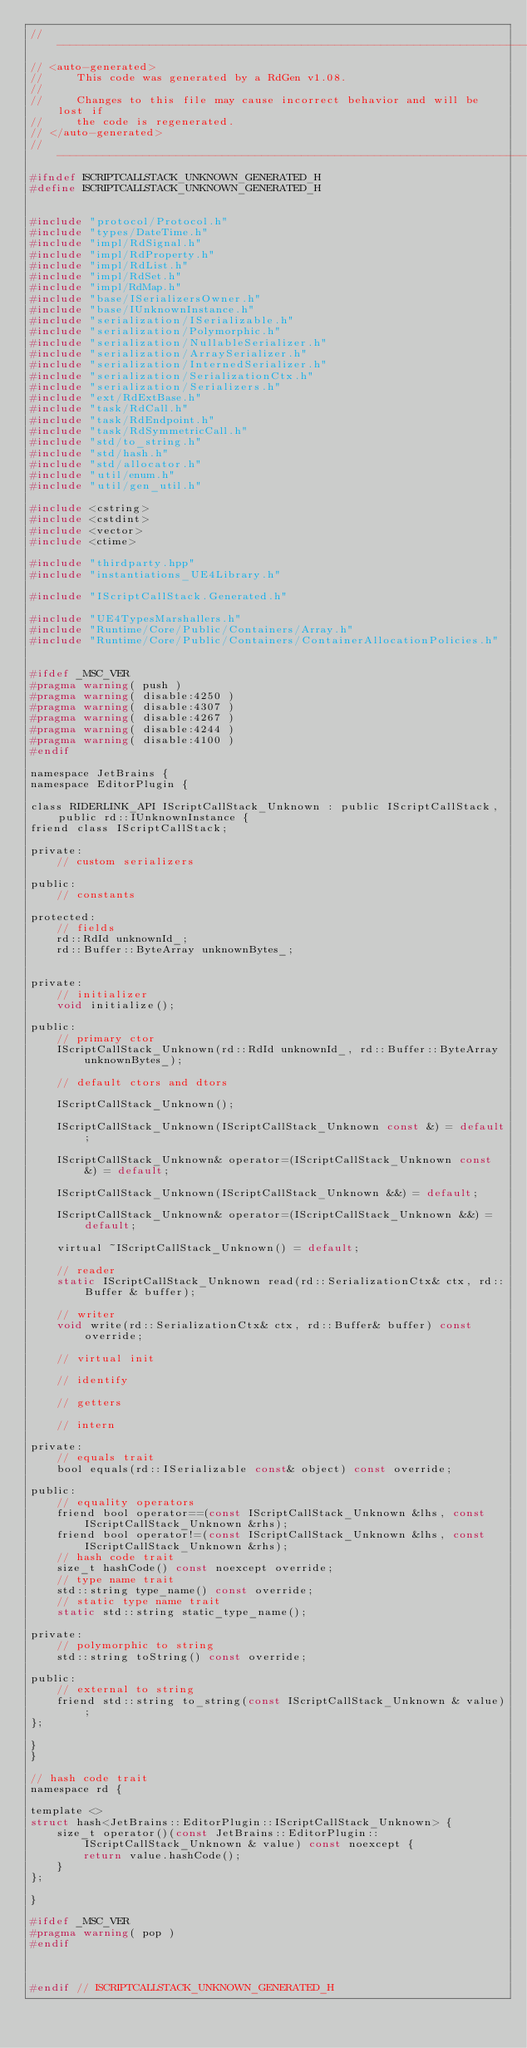<code> <loc_0><loc_0><loc_500><loc_500><_C_>//------------------------------------------------------------------------------
// <auto-generated>
//     This code was generated by a RdGen v1.08.
//
//     Changes to this file may cause incorrect behavior and will be lost if
//     the code is regenerated.
// </auto-generated>
//------------------------------------------------------------------------------
#ifndef ISCRIPTCALLSTACK_UNKNOWN_GENERATED_H
#define ISCRIPTCALLSTACK_UNKNOWN_GENERATED_H


#include "protocol/Protocol.h"
#include "types/DateTime.h"
#include "impl/RdSignal.h"
#include "impl/RdProperty.h"
#include "impl/RdList.h"
#include "impl/RdSet.h"
#include "impl/RdMap.h"
#include "base/ISerializersOwner.h"
#include "base/IUnknownInstance.h"
#include "serialization/ISerializable.h"
#include "serialization/Polymorphic.h"
#include "serialization/NullableSerializer.h"
#include "serialization/ArraySerializer.h"
#include "serialization/InternedSerializer.h"
#include "serialization/SerializationCtx.h"
#include "serialization/Serializers.h"
#include "ext/RdExtBase.h"
#include "task/RdCall.h"
#include "task/RdEndpoint.h"
#include "task/RdSymmetricCall.h"
#include "std/to_string.h"
#include "std/hash.h"
#include "std/allocator.h"
#include "util/enum.h"
#include "util/gen_util.h"

#include <cstring>
#include <cstdint>
#include <vector>
#include <ctime>

#include "thirdparty.hpp"
#include "instantiations_UE4Library.h"

#include "IScriptCallStack.Generated.h"

#include "UE4TypesMarshallers.h"
#include "Runtime/Core/Public/Containers/Array.h"
#include "Runtime/Core/Public/Containers/ContainerAllocationPolicies.h"


#ifdef _MSC_VER
#pragma warning( push )
#pragma warning( disable:4250 )
#pragma warning( disable:4307 )
#pragma warning( disable:4267 )
#pragma warning( disable:4244 )
#pragma warning( disable:4100 )
#endif

namespace JetBrains {
namespace EditorPlugin {

class RIDERLINK_API IScriptCallStack_Unknown : public IScriptCallStack, public rd::IUnknownInstance {
friend class IScriptCallStack;

private:
    // custom serializers

public:
    // constants

protected:
    // fields
    rd::RdId unknownId_;
    rd::Buffer::ByteArray unknownBytes_;
    

private:
    // initializer
    void initialize();

public:
    // primary ctor
    IScriptCallStack_Unknown(rd::RdId unknownId_, rd::Buffer::ByteArray unknownBytes_);
    
    // default ctors and dtors
    
    IScriptCallStack_Unknown();
    
    IScriptCallStack_Unknown(IScriptCallStack_Unknown const &) = default;
    
    IScriptCallStack_Unknown& operator=(IScriptCallStack_Unknown const &) = default;
    
    IScriptCallStack_Unknown(IScriptCallStack_Unknown &&) = default;
    
    IScriptCallStack_Unknown& operator=(IScriptCallStack_Unknown &&) = default;
    
    virtual ~IScriptCallStack_Unknown() = default;
    
    // reader
    static IScriptCallStack_Unknown read(rd::SerializationCtx& ctx, rd::Buffer & buffer);
    
    // writer
    void write(rd::SerializationCtx& ctx, rd::Buffer& buffer) const override;
    
    // virtual init
    
    // identify
    
    // getters
    
    // intern

private:
    // equals trait
    bool equals(rd::ISerializable const& object) const override;

public:
    // equality operators
    friend bool operator==(const IScriptCallStack_Unknown &lhs, const IScriptCallStack_Unknown &rhs);
    friend bool operator!=(const IScriptCallStack_Unknown &lhs, const IScriptCallStack_Unknown &rhs);
    // hash code trait
    size_t hashCode() const noexcept override;
    // type name trait
    std::string type_name() const override;
    // static type name trait
    static std::string static_type_name();

private:
    // polymorphic to string
    std::string toString() const override;

public:
    // external to string
    friend std::string to_string(const IScriptCallStack_Unknown & value);
};

}
}

// hash code trait
namespace rd {

template <>
struct hash<JetBrains::EditorPlugin::IScriptCallStack_Unknown> {
    size_t operator()(const JetBrains::EditorPlugin::IScriptCallStack_Unknown & value) const noexcept {
        return value.hashCode();
    }
};

}

#ifdef _MSC_VER
#pragma warning( pop )
#endif



#endif // ISCRIPTCALLSTACK_UNKNOWN_GENERATED_H
</code> 